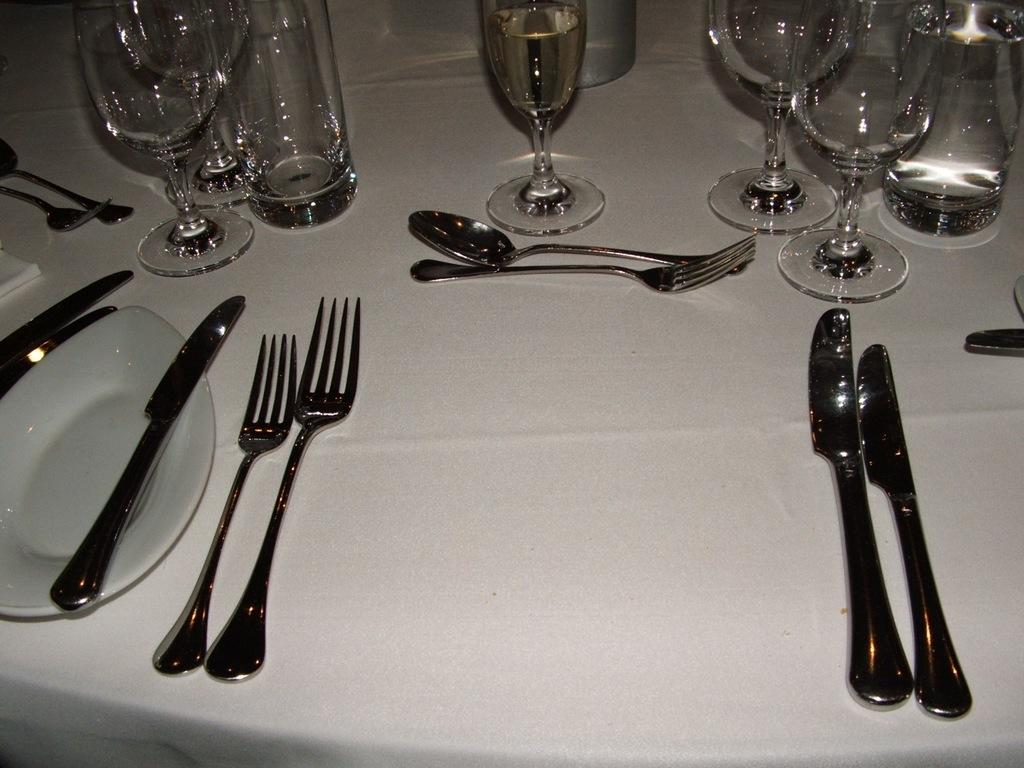What type of furniture is present in the image? There is a table in the image. What is covering the table? The table has a table cloth. What types of utensils are on the table? There are knives, spoons, and forks on the table. What is used for drinking in the image? There are glasses on the table. What is used for pouring liquids in the image? There are bottles on the table. What is used for wiping or blowing one's nose in the image? There is a tissue paper on the table. What is used for serving food in the image? There is a plate on the table. What color is the ink on the table in the image? There is no ink present on the table in the image. How many legs does the table have in the image? The number of legs on the table cannot be determined from the image alone, as the table is not shown from all angles. 